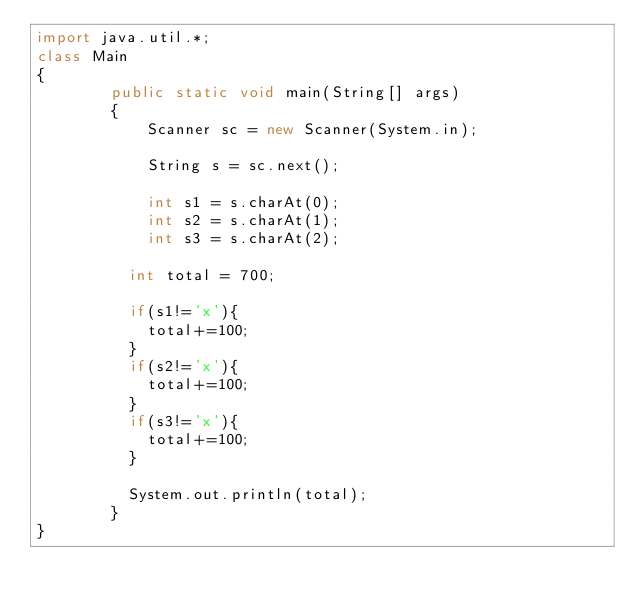<code> <loc_0><loc_0><loc_500><loc_500><_Java_>import java.util.*;
class Main
{
		public static void main(String[] args) 
		{
			Scanner sc = new Scanner(System.in);
			
			String s = sc.next();
			
			int s1 = s.charAt(0);
			int s2 = s.charAt(1);
			int s3 = s.charAt(2);
          	
          int total = 700;
          
          if(s1!='x'){
            total+=100;
          }
          if(s2!='x'){
            total+=100;
          }
          if(s3!='x'){
            total+=100;
          }
          
          System.out.println(total);
        }
}</code> 